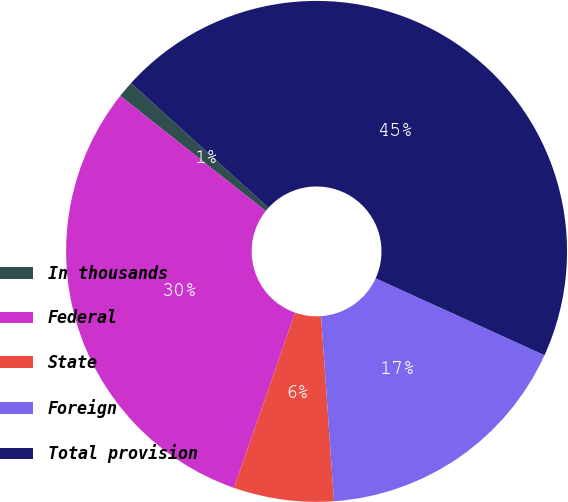Convert chart to OTSL. <chart><loc_0><loc_0><loc_500><loc_500><pie_chart><fcel>In thousands<fcel>Federal<fcel>State<fcel>Foreign<fcel>Total provision<nl><fcel>1.06%<fcel>30.31%<fcel>6.46%<fcel>17.09%<fcel>45.08%<nl></chart> 